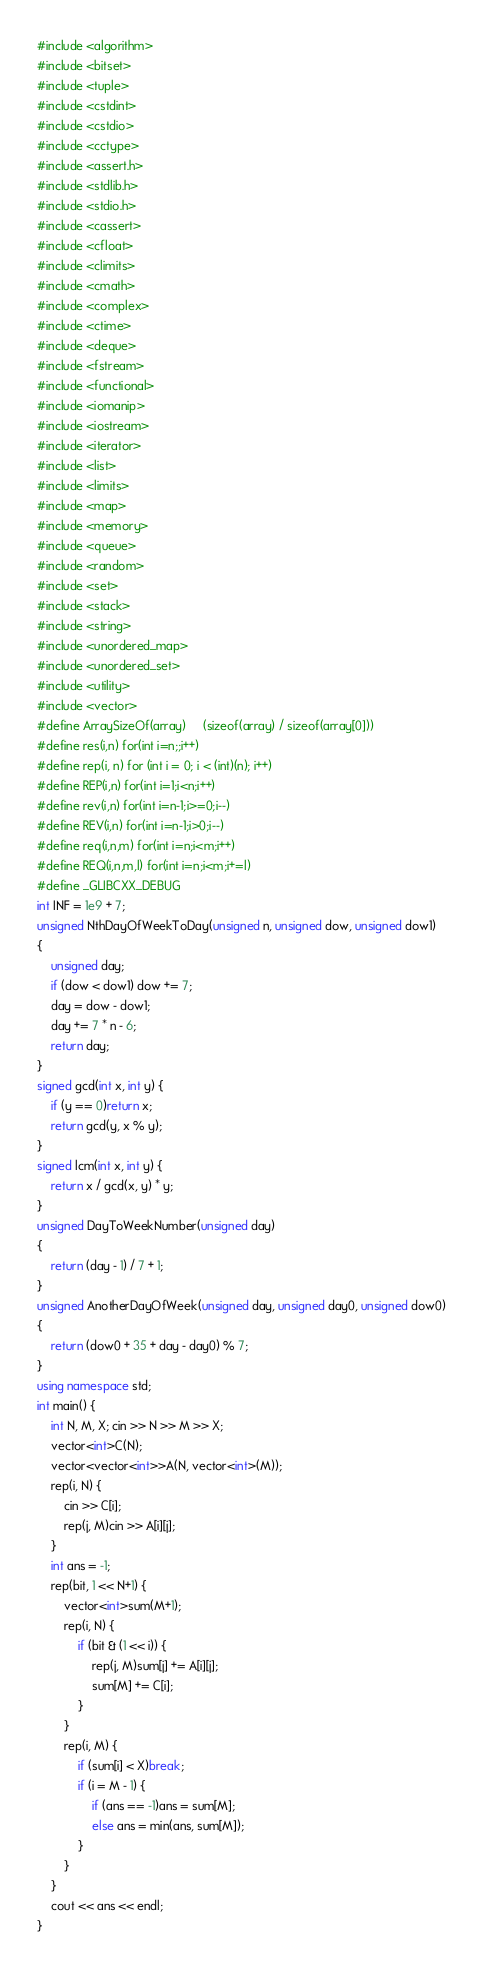Convert code to text. <code><loc_0><loc_0><loc_500><loc_500><_C++_>#include <algorithm>
#include <bitset>
#include <tuple>
#include <cstdint>
#include <cstdio>
#include <cctype>
#include <assert.h>
#include <stdlib.h>
#include <stdio.h>
#include <cassert>
#include <cfloat>
#include <climits>
#include <cmath>
#include <complex>
#include <ctime>
#include <deque>
#include <fstream>
#include <functional>
#include <iomanip>
#include <iostream>
#include <iterator>
#include <list>
#include <limits>
#include <map>
#include <memory>
#include <queue>
#include <random>
#include <set>
#include <stack>
#include <string>
#include <unordered_map>
#include <unordered_set>
#include <utility>
#include <vector>
#define ArraySizeOf(array)     (sizeof(array) / sizeof(array[0]))
#define res(i,n) for(int i=n;;i++)
#define rep(i, n) for (int i = 0; i < (int)(n); i++)
#define REP(i,n) for(int i=1;i<n;i++)
#define rev(i,n) for(int i=n-1;i>=0;i--)
#define REV(i,n) for(int i=n-1;i>0;i--)
#define req(i,n,m) for(int i=n;i<m;i++)
#define REQ(i,n,m,l) for(int i=n;i<m;i+=l) 
#define _GLIBCXX_DEBUG
int INF = 1e9 + 7;
unsigned NthDayOfWeekToDay(unsigned n, unsigned dow, unsigned dow1)
{
    unsigned day;
    if (dow < dow1) dow += 7;
    day = dow - dow1;
    day += 7 * n - 6;
    return day;
}
signed gcd(int x, int y) {
    if (y == 0)return x;
    return gcd(y, x % y);
}
signed lcm(int x, int y) {
    return x / gcd(x, y) * y;
}
unsigned DayToWeekNumber(unsigned day)
{
    return (day - 1) / 7 + 1;
}
unsigned AnotherDayOfWeek(unsigned day, unsigned day0, unsigned dow0)
{
    return (dow0 + 35 + day - day0) % 7;
}
using namespace std;
int main() {
    int N, M, X; cin >> N >> M >> X;
    vector<int>C(N);
    vector<vector<int>>A(N, vector<int>(M));
    rep(i, N) {
        cin >> C[i];
        rep(j, M)cin >> A[i][j];
    }
    int ans = -1;
    rep(bit, 1 << N+1) {
        vector<int>sum(M+1);
        rep(i, N) {
            if (bit & (1 << i)) {
                rep(j, M)sum[j] += A[i][j];
                sum[M] += C[i];
            }
        }
        rep(i, M) {
            if (sum[i] < X)break;
            if (i = M - 1) {
                if (ans == -1)ans = sum[M];
                else ans = min(ans, sum[M]);
            }
        }
    }
    cout << ans << endl;
}</code> 